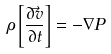<formula> <loc_0><loc_0><loc_500><loc_500>\rho \left [ \frac { \partial \vec { v } } { \partial t } \right ] = - \nabla P</formula> 